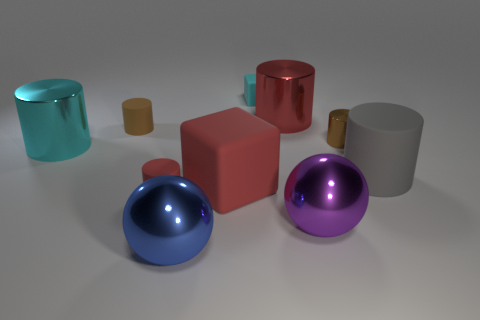Is the number of large cylinders to the left of the large rubber cylinder greater than the number of brown rubber cylinders?
Your response must be concise. Yes. There is a rubber cylinder that is behind the gray rubber object; does it have the same color as the small rubber block?
Your answer should be very brief. No. Are there any other things that have the same color as the big rubber cylinder?
Provide a succinct answer. No. What is the color of the tiny rubber cylinder that is behind the tiny matte cylinder in front of the cyan metal thing that is behind the gray cylinder?
Keep it short and to the point. Brown. Is the size of the cyan metallic cylinder the same as the red rubber cylinder?
Your answer should be very brief. No. What number of shiny cylinders have the same size as the red block?
Provide a succinct answer. 2. There is a shiny thing that is the same color as the small matte block; what shape is it?
Offer a very short reply. Cylinder. Do the big red object in front of the big red shiny object and the small brown cylinder that is left of the small cyan matte cube have the same material?
Your answer should be very brief. Yes. What is the color of the large matte cylinder?
Your answer should be compact. Gray. How many brown things have the same shape as the big cyan metal thing?
Your answer should be very brief. 2. 